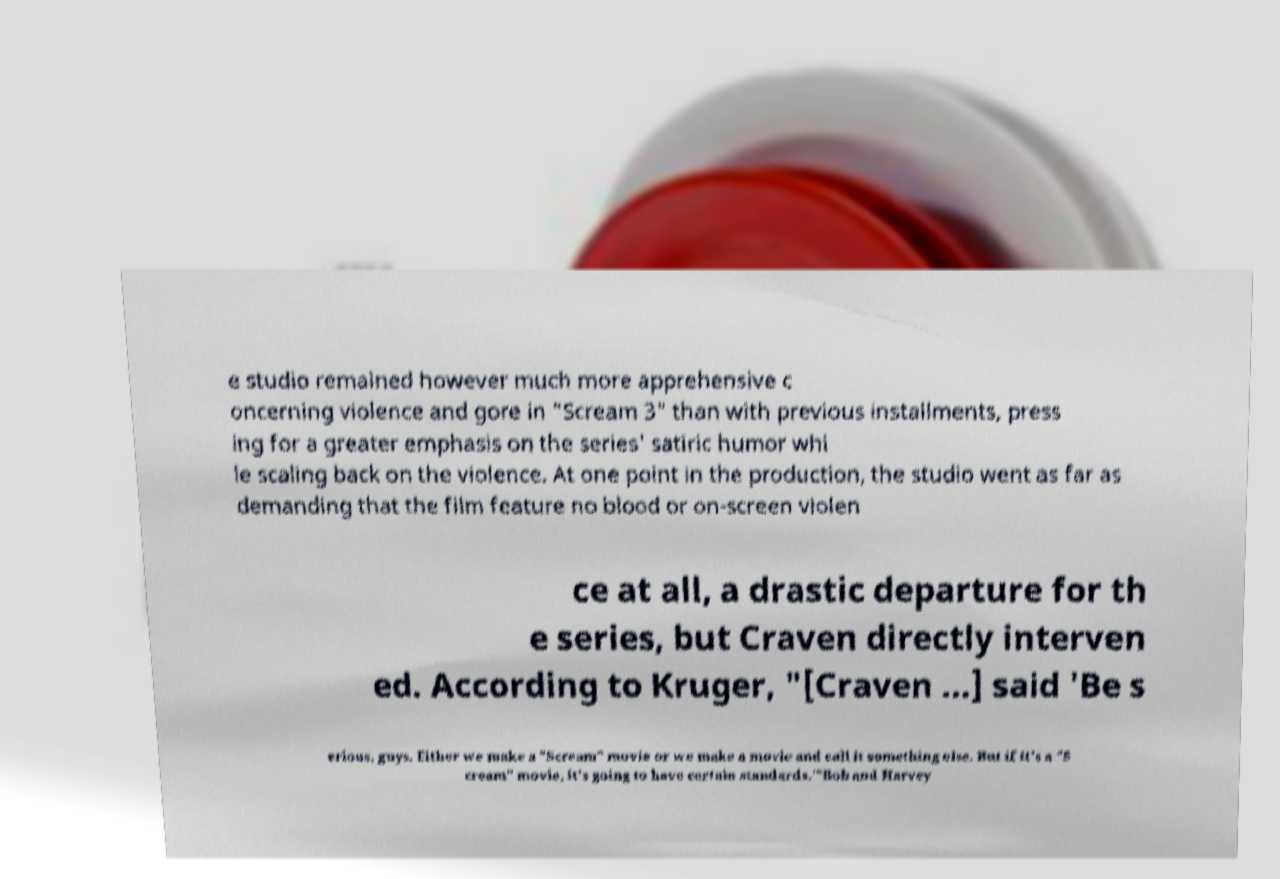Please read and relay the text visible in this image. What does it say? e studio remained however much more apprehensive c oncerning violence and gore in "Scream 3" than with previous installments, press ing for a greater emphasis on the series' satiric humor whi le scaling back on the violence. At one point in the production, the studio went as far as demanding that the film feature no blood or on-screen violen ce at all, a drastic departure for th e series, but Craven directly interven ed. According to Kruger, "[Craven ...] said 'Be s erious, guys. Either we make a "Scream" movie or we make a movie and call it something else. But if it's a "S cream" movie, it's going to have certain standards.'"Bob and Harvey 